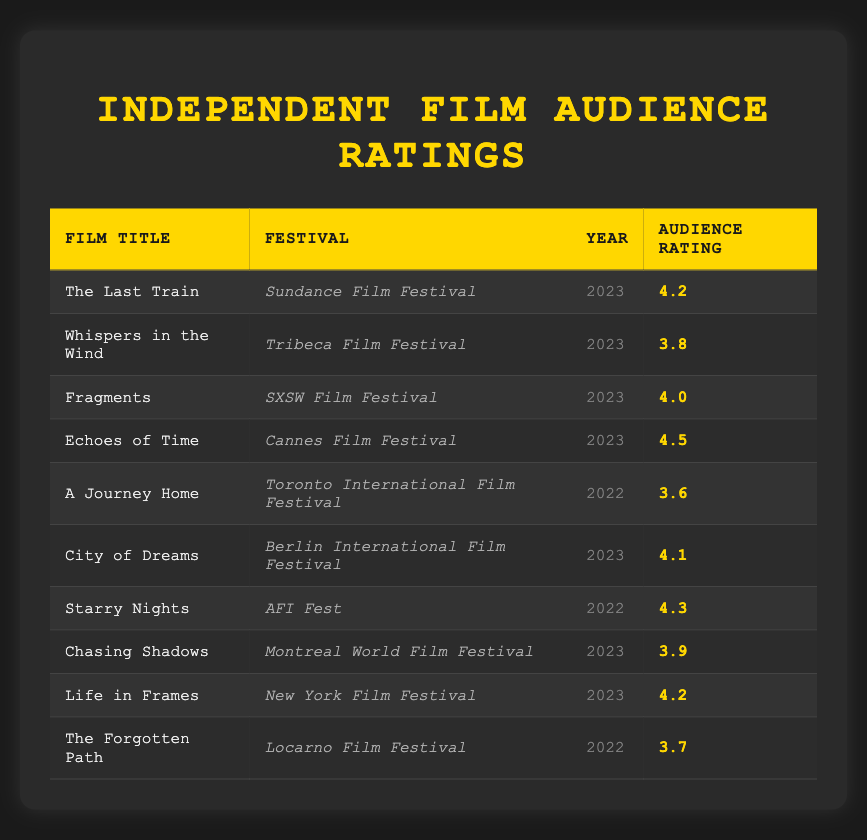What is the highest audience rating among the films? To find the highest audience rating, we need to look through the audience rating column and identify the maximum value. The ratings are 4.2, 3.8, 4.0, 4.5, 3.6, 4.1, 4.3, 3.9, 4.2, and 3.7. The highest among these is 4.5 from "Echoes of Time."
Answer: 4.5 How many films have an audience rating of 4.2? By checking the audience rating column for the value 4.2, we can see that there are two films with this rating: "The Last Train" and "Life in Frames."
Answer: 2 What is the average audience rating of all films listed? To find the average, we sum up all the ratings: 4.2 + 3.8 + 4.0 + 4.5 + 3.6 + 4.1 + 4.3 + 3.9 + 4.2 + 3.7 = 43.3. Then, we divide by the number of films, which is 10. Therefore, the average rating is 43.3 / 10 = 4.33.
Answer: 4.33 Did any films receive audience ratings below 4.0? We can assess the audience ratings to see if any are below 4.0. The ratings are 4.2, 3.8, 4.0, 4.5, 3.6, 4.1, 4.3, 3.9, 4.2, and 3.7. The ratings 3.8, 3.6, and 3.7 are indeed below 4.0.
Answer: Yes Which festival had the film with the lowest rating? To answer, we need to identify the film with the lowest audience rating in the table, which is 3.6 from "A Journey Home" at the Toronto International Film Festival.
Answer: Toronto International Film Festival 